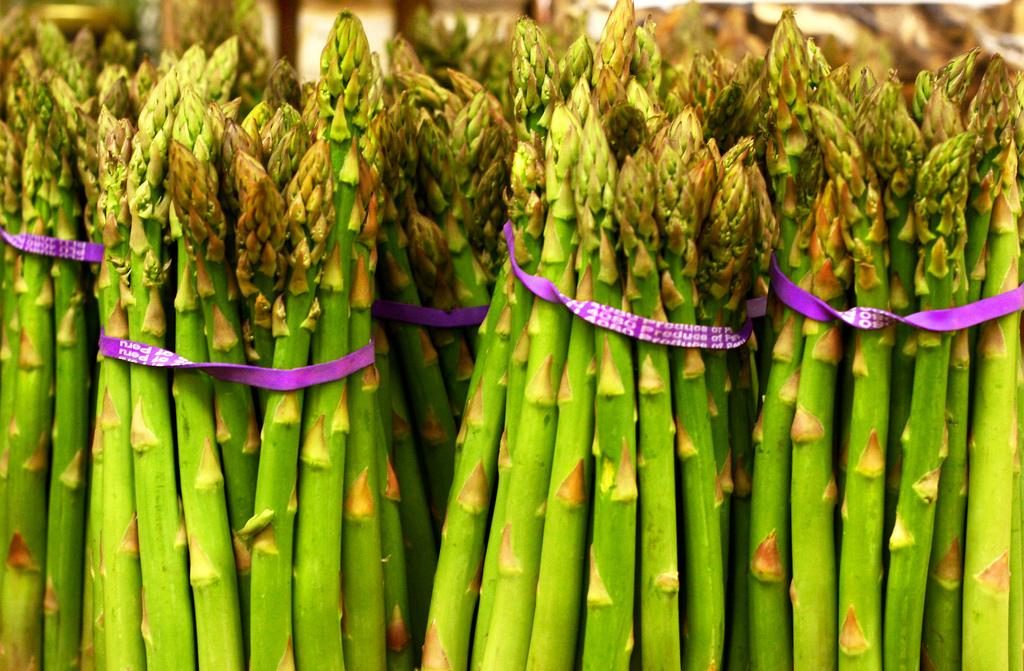What type of vegetable is featured in the image? There are bunches of asparagus in the image. How are the asparagus arranged in the image? The asparagus are arranged in bunches. What can be inferred about the purpose of the image? The image may be showcasing the asparagus or providing information about them. What type of government is depicted in the image? There is no government depicted in the image; it features bunches of asparagus. How many cows are visible in the image? There are no cows present in the image; it features bunches of asparagus. 